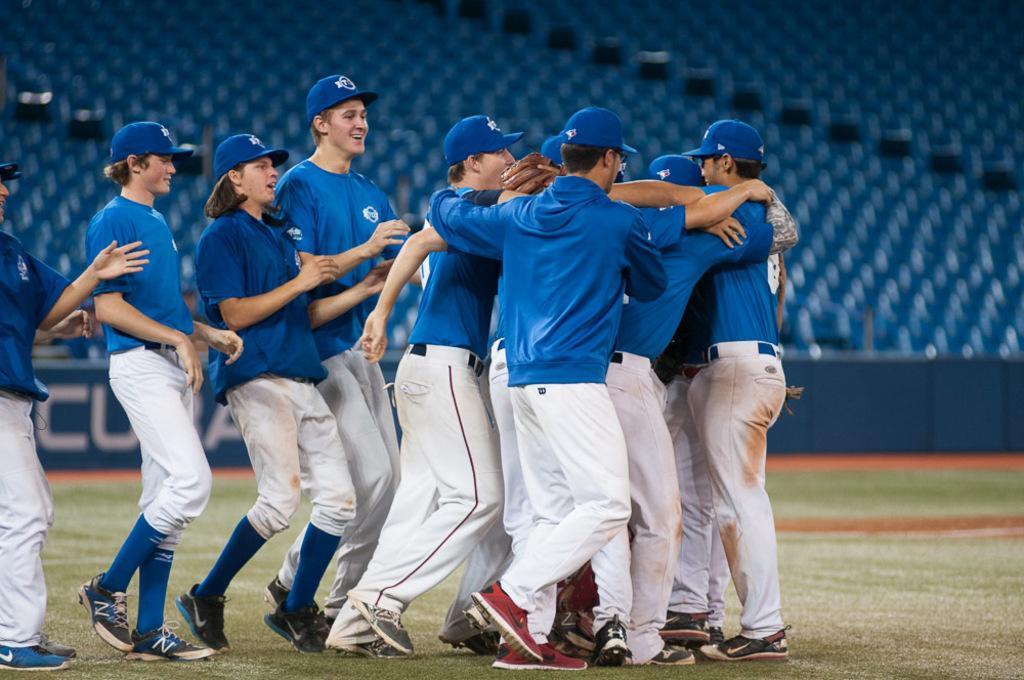Can you describe this image briefly? In this image there are people standing on the grass. Behind them there is a banner with some text on it. In the background of the image there are chairs. 